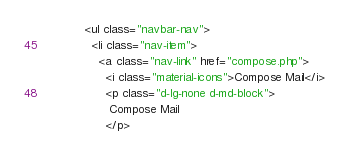<code> <loc_0><loc_0><loc_500><loc_500><_HTML_>            <ul class="navbar-nav">
              <li class="nav-item">
                <a class="nav-link" href="compose.php">
                  <i class="material-icons">Compose Mail</i>
                  <p class="d-lg-none d-md-block">
                   Compose Mail
                  </p></code> 